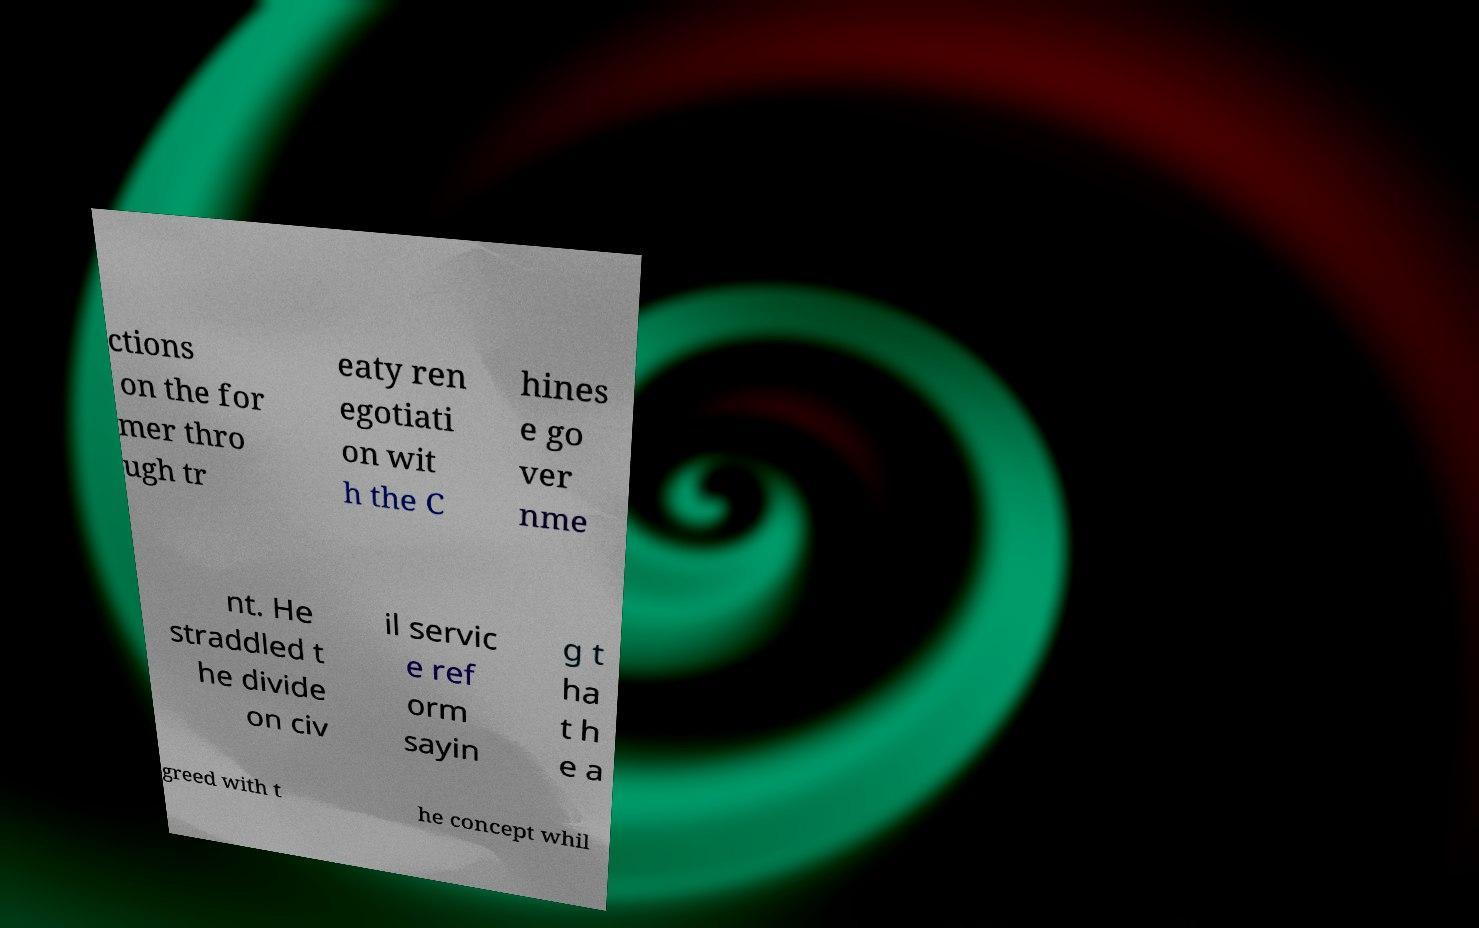Could you assist in decoding the text presented in this image and type it out clearly? ctions on the for mer thro ugh tr eaty ren egotiati on wit h the C hines e go ver nme nt. He straddled t he divide on civ il servic e ref orm sayin g t ha t h e a greed with t he concept whil 